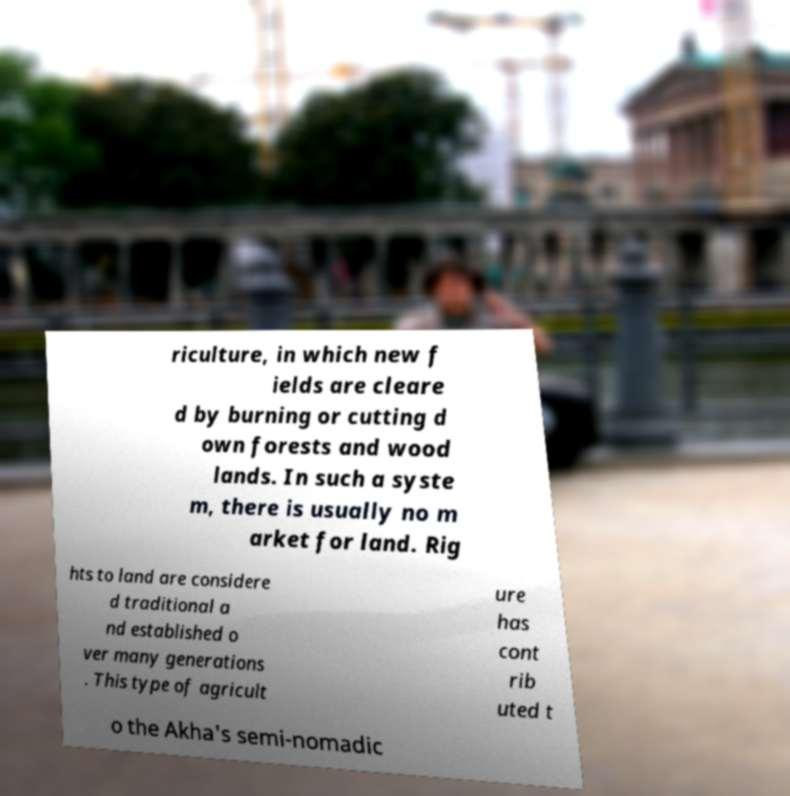Can you read and provide the text displayed in the image?This photo seems to have some interesting text. Can you extract and type it out for me? riculture, in which new f ields are cleare d by burning or cutting d own forests and wood lands. In such a syste m, there is usually no m arket for land. Rig hts to land are considere d traditional a nd established o ver many generations . This type of agricult ure has cont rib uted t o the Akha's semi-nomadic 